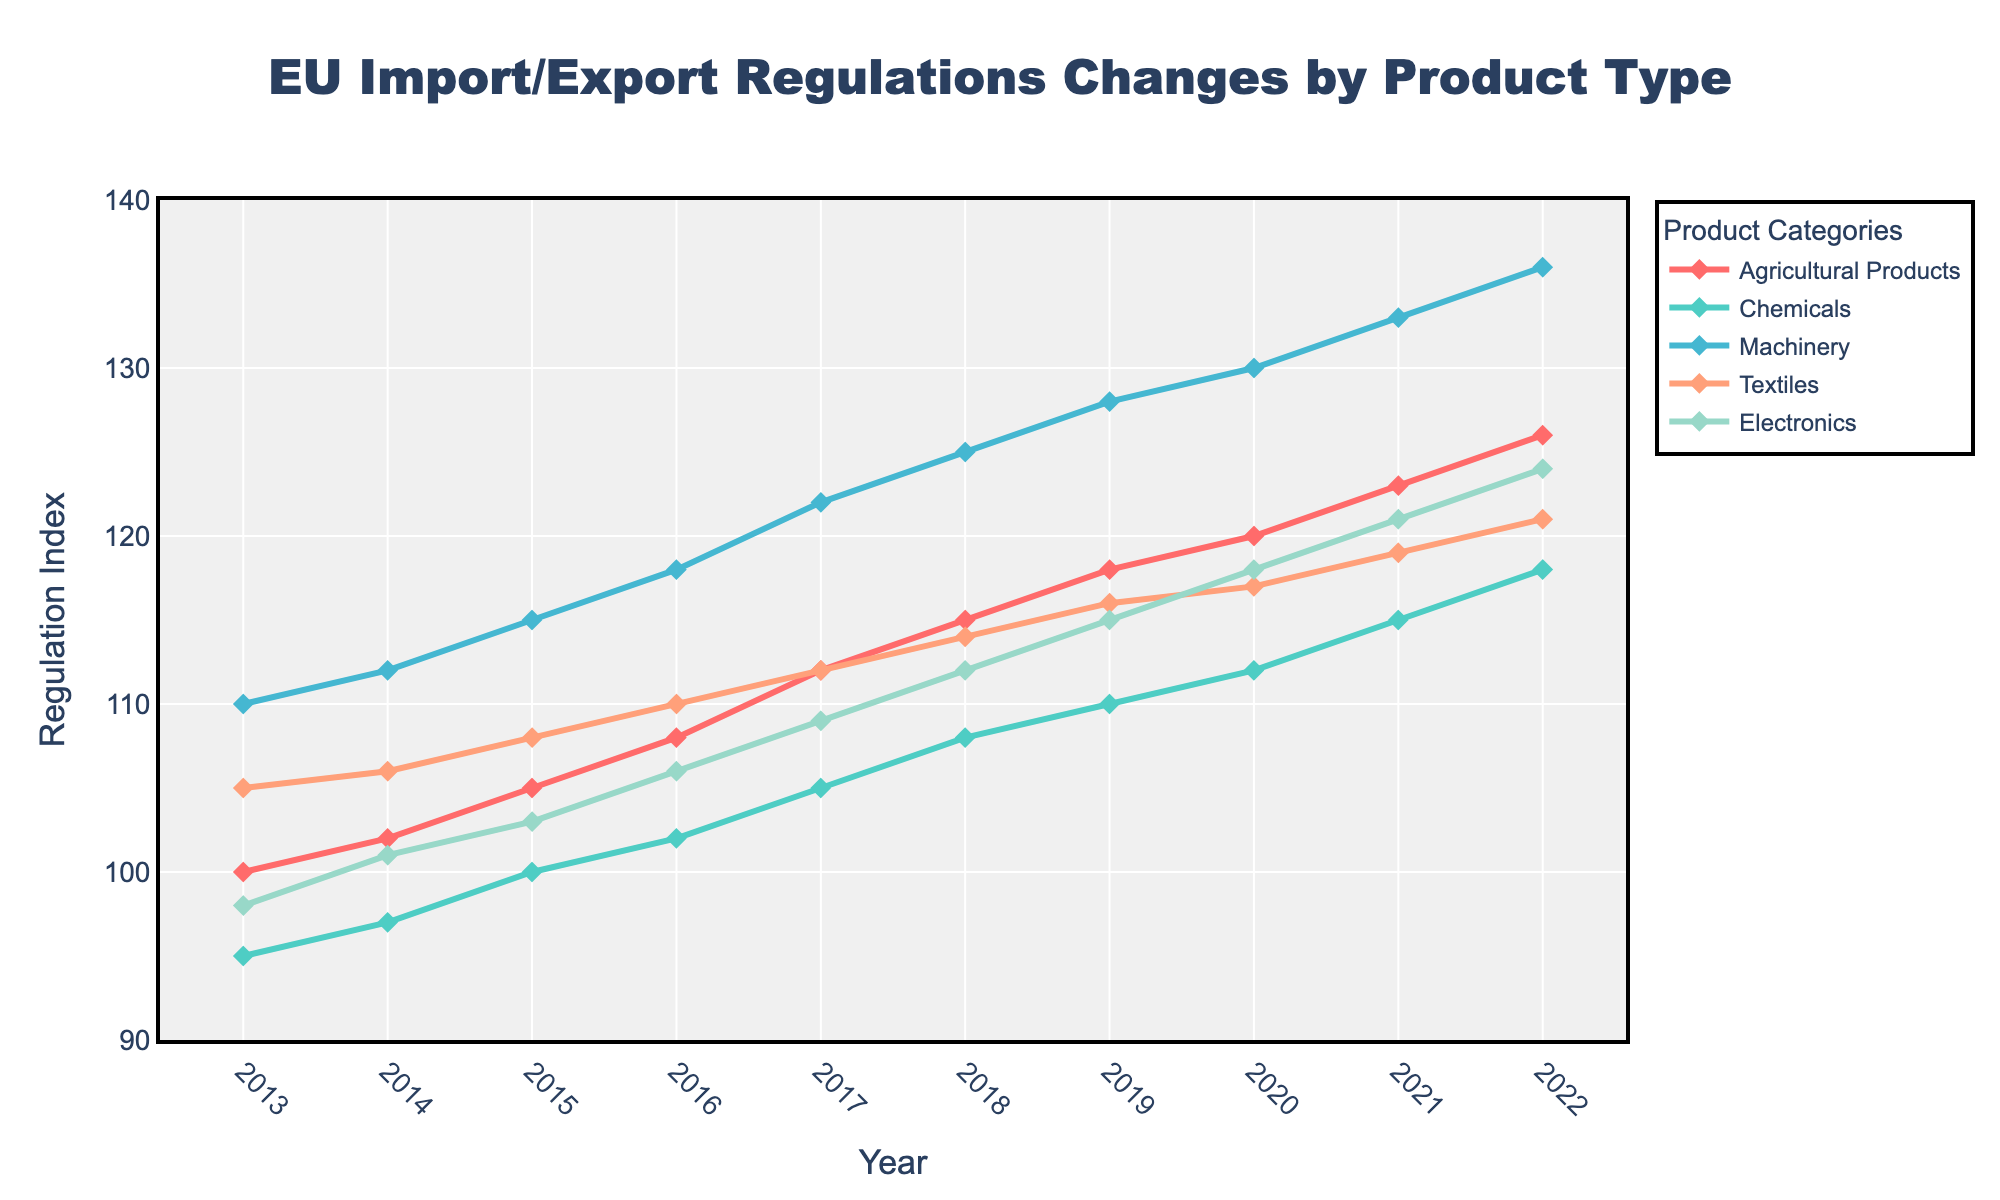What was the change in regulation index for Agricultural Products from 2013 to 2022? To find the change, subtract the regulation index in 2013 from the regulation index in 2022. The index for Agricultural Products in 2013 was 100, and in 2022 it was 126. So, the change is 126 - 100 = 26.
Answer: 26 Which product type experienced the highest increase in regulation index over the decade? Compare the changes in regulation indices for all product types over the decade. Agricultural Products increased from 100 to 126, Chemicals from 95 to 118, Machinery from 110 to 136, Textiles from 105 to 121, and Electronics from 98 to 124. The highest increase is for Machinery, with an increase of 136 - 110 = 26.
Answer: Machinery In which years did Chemicals and Textiles have the same regulation index? Look for the years where the regulation indices for Chemicals and Textiles are equal. By inspecting the data, we see that in no year did Chemicals and Textiles have the same regulation index.
Answer: None What is the average regulation index for Electronics over the entire period? To find the average regulation index for Electronics, sum all the yearly indices and divide by the number of years. (98+101+103+106+109+112+115+118+121+124) / 10 = 1110 / 10 = 111.
Answer: 111 Which product type had the smallest increase in regulation index from 2017 to 2022? Subtract the 2017 regulation index from the 2022 index for each product type. The increases are: Agricultural Products (126-112=14), Chemicals (118-105=13), Machinery (136-122=14), Textiles (121-112=9), Electronics (124-109=15). The smallest increase is for Textiles.
Answer: Textiles How does the regulation index for Textiles in 2022 compare to the regulation index for Chemicals in 2020? The regulation index for Textiles in 2022 is 121, and for Chemicals in 2020 is 112. Comparison shows that Textiles have a higher regulation index in 2022.
Answer: Textiles have a higher index Which year saw the largest increase in regulation index for Agricultural Products? Calculate the yearly increase for Agricultural Products and find the year with the largest jump. The increases are: (102-100=2), (105-102=3), (108-105=3), (112-108=4), (115-112=3), (118-115=3), (120-118=2), (123-120=3), (126-123=3). The largest increase was 4, from 2016 to 2017.
Answer: 2017 Is there a year where all product types' regulation indices were higher than the previous year? Check if there is a year in which every product type's index increased compared to the previous year. By inspecting the data, in every year from 2013 to 2022, the regulation indices for all product types increased compared to the previous year.
Answer: 2013-2022 Between 2015 and 2018, which product type showed the most consistent year-over-year increase? Calculate the year-over-year increase between 2015 and 2018 for each product. Agricultural Products: (108-105=3), (112-108=4), (115-112=3). Chemicals: (102-100=2), (105-102=3), (108-105=3). Machinery: (118-115=3), (122-118=4), (125-122=3). Textiles: (110-108=2), (112-110=2), (114-112=2). Electronics: (106-103=3), (109-106=3), (112-109=3). Textiles had consistent increases of 2 each year.
Answer: Textiles By how much did the regulation index for Machinery exceed Chemicals in 2022? Subtract the regulation index of Chemicals from Machinery in 2022. Machinery: 136, Chemicals: 118, difference is 136 - 118 = 18.
Answer: 18 